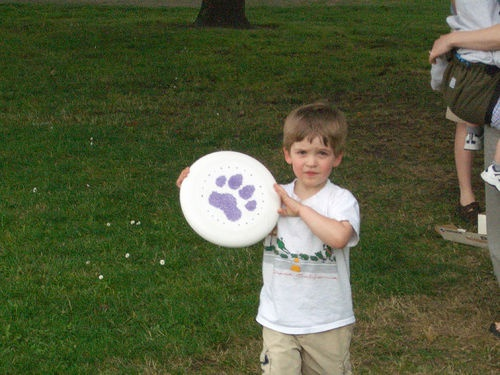Describe the objects in this image and their specific colors. I can see people in black, lightgray, darkgray, and tan tones, frisbee in black, white, darkgray, and gray tones, people in black, darkgray, and gray tones, people in black, gray, tan, and darkgray tones, and handbag in black and darkgreen tones in this image. 